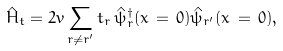Convert formula to latex. <formula><loc_0><loc_0><loc_500><loc_500>\hat { H } _ { t } = 2 v \sum _ { r \ne r ^ { \prime } } t _ { r } \, \hat { \psi } _ { r } ^ { \dagger } ( x \, = \, 0 ) \hat { \psi } _ { r ^ { \prime } } ( x \, = \, 0 ) ,</formula> 